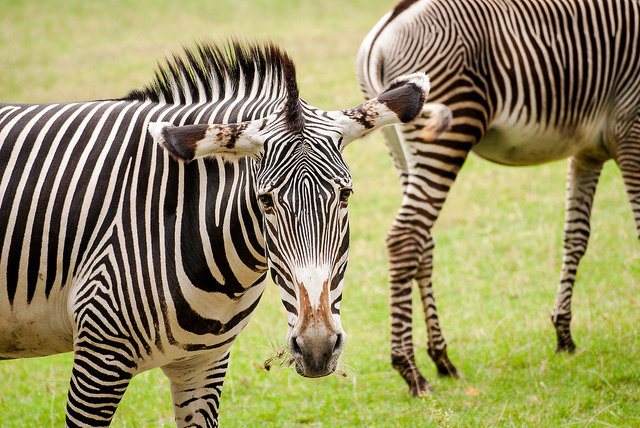Can you elaborate on the elements of the picture provided? Certainly! The image showcases a pair of zebras standing on grass. The zebra in the foreground is facing the viewer and presents a striking face-on view, allowing us to see its eyes, ears, and the unique pattern of stripes. The other zebra is positioned to the right and slightly behind the first, offering a side profile which beautifully displays the contours of its body and the consistency of the stripe pattern. The lush green background suggests a natural habitat, which could be a savanna or a protected area. Both zebras appear calm and composed, and there's a sense of serene co-existence between them and their environment. 